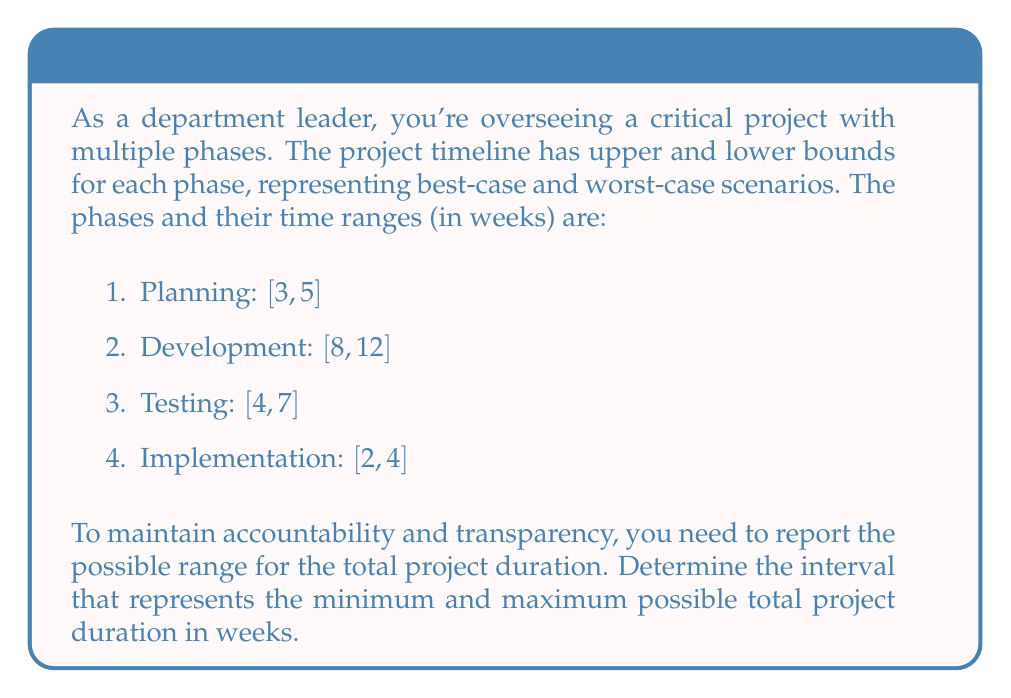Teach me how to tackle this problem. To solve this problem, we need to find the lower and upper bounds for the total project duration:

1. Lower bound (best-case scenario):
   We sum the minimum values for each phase:
   $$3 + 8 + 4 + 2 = 17\text{ weeks}$$

2. Upper bound (worst-case scenario):
   We sum the maximum values for each phase:
   $$5 + 12 + 7 + 4 = 28\text{ weeks}$$

The interval notation for this range is $[17, 28]$, which means the project could take anywhere from 17 to 28 weeks.

This approach allows for transparency in reporting, as it accounts for both optimistic and pessimistic scenarios, providing a realistic range for project stakeholders to consider.
Answer: The interval representing the minimum and maximum possible total project duration is $[17, 28]$ weeks. 